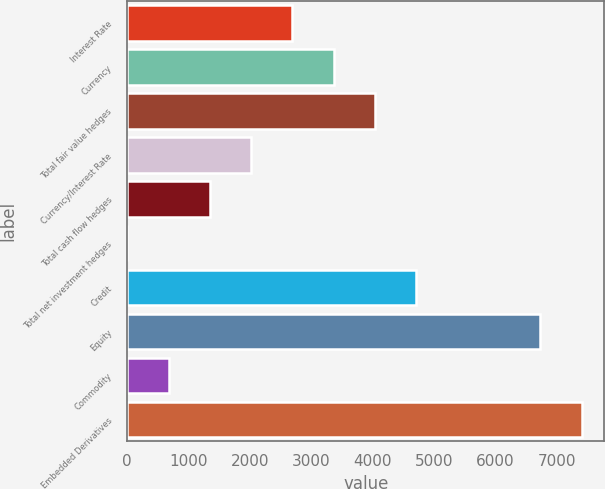Convert chart. <chart><loc_0><loc_0><loc_500><loc_500><bar_chart><fcel>Interest Rate<fcel>Currency<fcel>Total fair value hedges<fcel>Currency/Interest Rate<fcel>Total cash flow hedges<fcel>Total net investment hedges<fcel>Credit<fcel>Equity<fcel>Commodity<fcel>Embedded Derivatives<nl><fcel>2694.06<fcel>3367.39<fcel>4040.72<fcel>2020.73<fcel>1347.4<fcel>0.74<fcel>4714.05<fcel>6734.04<fcel>674.07<fcel>7407.37<nl></chart> 